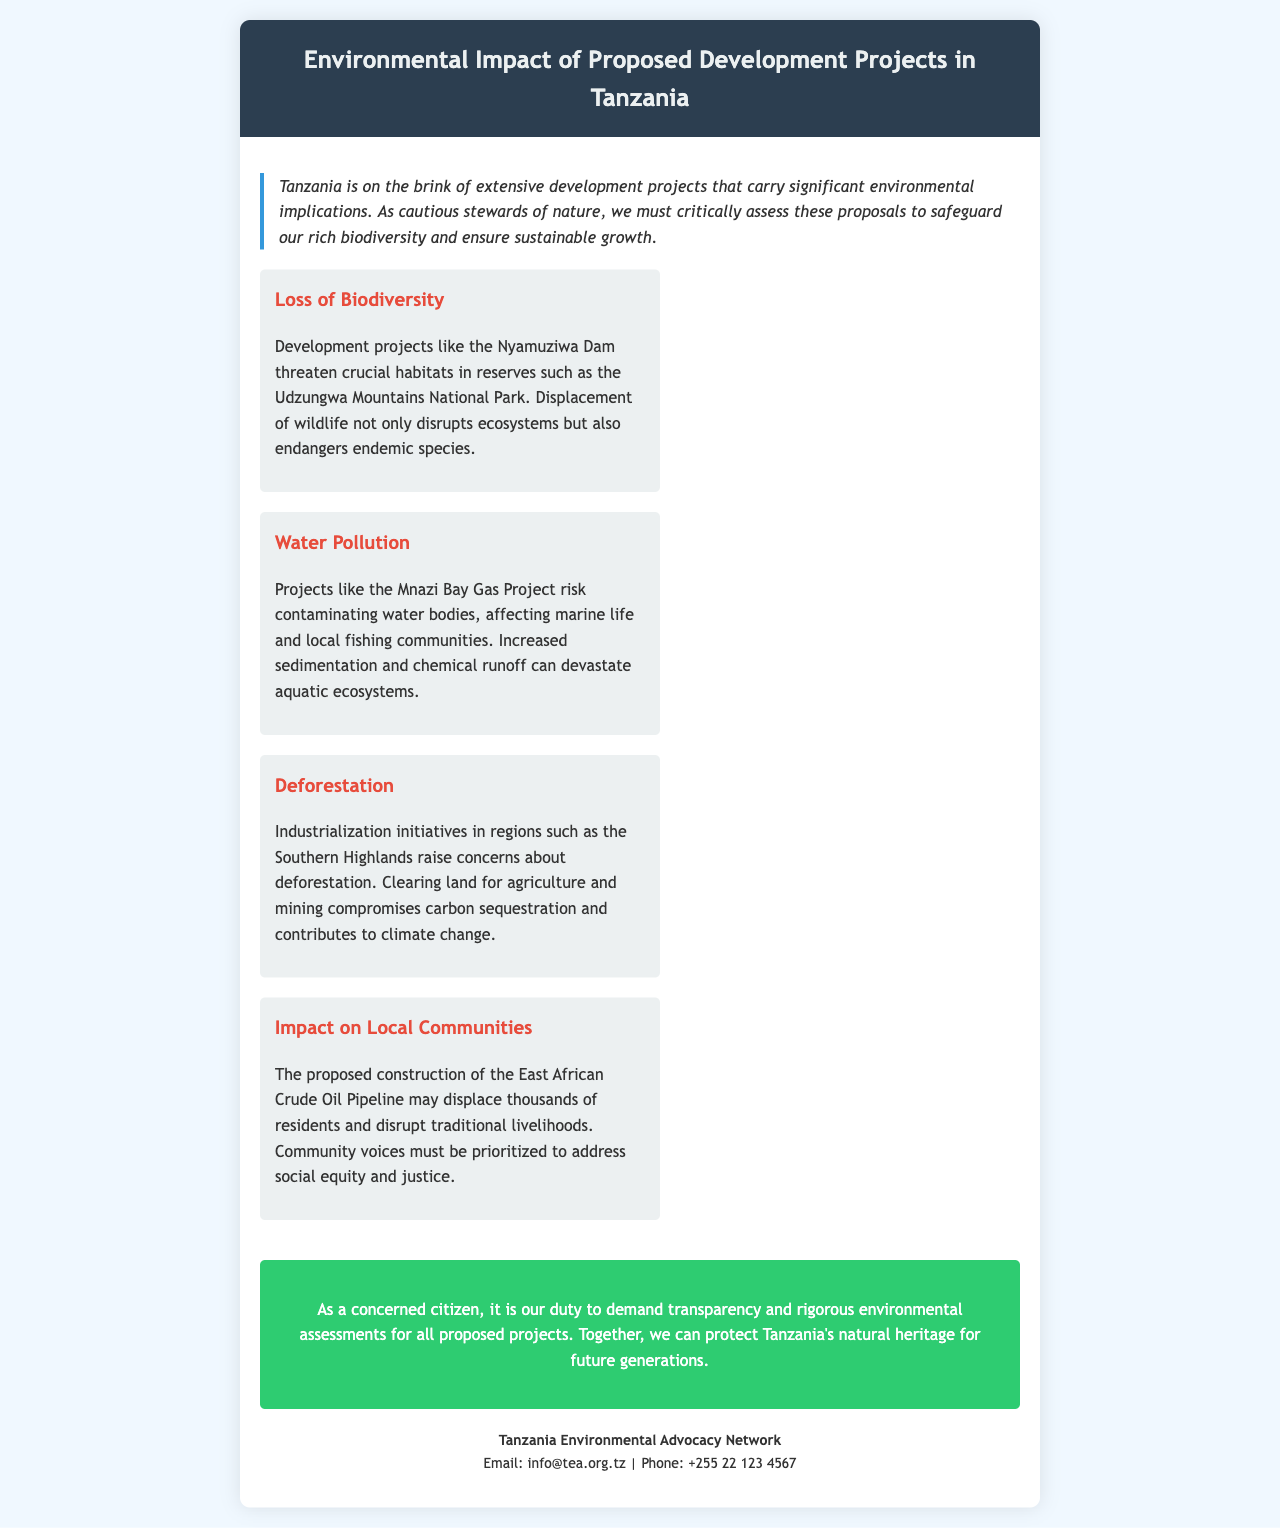what is the main topic of the brochure? The brochure addresses the environmental impact of proposed development projects in Tanzania.
Answer: Environmental Impact of Proposed Development Projects in Tanzania which project threatens crucial habitats in reserves? The Nyamuziwa Dam threatens crucial habitats in reserves.
Answer: Nyamuziwa Dam what type of pollution is a concern with the Mnazi Bay Gas Project? The brochure highlights water pollution as a concern with the Mnazi Bay Gas Project.
Answer: Water Pollution what region is mentioned concerning deforestation? The Southern Highlands region is mentioned in relation to deforestation.
Answer: Southern Highlands how many residents may be displaced by the East African Crude Oil Pipeline? The document states that thousands of residents may be displaced by the East African Crude Oil Pipeline.
Answer: Thousands who is the organization responsible for the brochure? The brochure is issued by the Tanzania Environmental Advocacy Network.
Answer: Tanzania Environmental Advocacy Network what is the purpose of the call-to-action in the brochure? The call-to-action emphasizes the need for transparency and rigorous environmental assessments.
Answer: Transparency and rigorous environmental assessments what contact method is provided in the brochure? The brochure provides an email address for contact purposes.
Answer: Email: info@tea.org.tz what style feature highlights the introduction? The introduction is highlighted by an italic font style and a border.
Answer: Italic font style and a border 